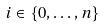Convert formula to latex. <formula><loc_0><loc_0><loc_500><loc_500>i \in \{ 0 , \dots , n \}</formula> 